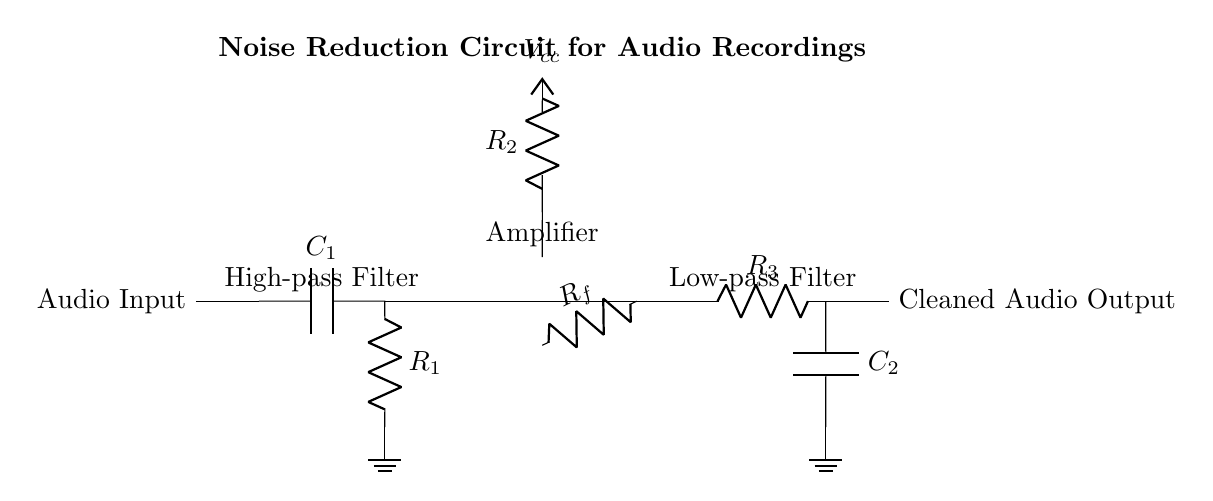What is the first component in the circuit? The first component is labeled Audio Input, indicating where the audio signal enters the circuit.
Answer: Audio Input What type of filter is used after the Audio Input? Following the Audio Input, a high-pass filter is depicted with a capacitor and resistor.
Answer: High-pass filter What is the purpose of the amplifier in the circuit? The amplifier increases the amplitude of the audio signal, making it stronger for further processing by the filters.
Answer: To amplify audio What are the values of the two resistors in the amplifier section? The indicated resistors in the amplifier section are labeled Rf and R2. Without specific values provided, we can identify their roles rather than specific numerical values.
Answer: Rf and R2 How does the signal flow from the input to the output? The signal flows from Audio Input to the high-pass filter, then to the amplifier, followed by the low-pass filter, and finally to the Cleaned Audio Output. This sequence ensures both high-frequency noise and low-frequency noise are managed.
Answer: Input to output through filters and amplifier What is the role of C1 in the noise reduction circuit? C1 serves as the capacitor in the high-pass filter, allowing high-frequency signals to pass while blocking lower frequencies, which helps reduce noise from the audio recording.
Answer: To block low frequencies 